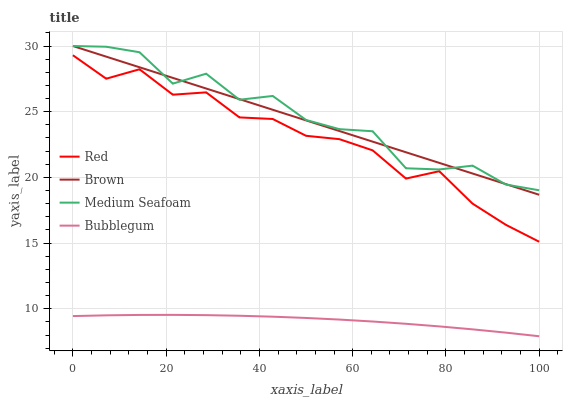Does Bubblegum have the minimum area under the curve?
Answer yes or no. Yes. Does Medium Seafoam have the maximum area under the curve?
Answer yes or no. Yes. Does Medium Seafoam have the minimum area under the curve?
Answer yes or no. No. Does Bubblegum have the maximum area under the curve?
Answer yes or no. No. Is Brown the smoothest?
Answer yes or no. Yes. Is Medium Seafoam the roughest?
Answer yes or no. Yes. Is Bubblegum the smoothest?
Answer yes or no. No. Is Bubblegum the roughest?
Answer yes or no. No. Does Bubblegum have the lowest value?
Answer yes or no. Yes. Does Medium Seafoam have the lowest value?
Answer yes or no. No. Does Medium Seafoam have the highest value?
Answer yes or no. Yes. Does Bubblegum have the highest value?
Answer yes or no. No. Is Bubblegum less than Medium Seafoam?
Answer yes or no. Yes. Is Medium Seafoam greater than Red?
Answer yes or no. Yes. Does Brown intersect Medium Seafoam?
Answer yes or no. Yes. Is Brown less than Medium Seafoam?
Answer yes or no. No. Is Brown greater than Medium Seafoam?
Answer yes or no. No. Does Bubblegum intersect Medium Seafoam?
Answer yes or no. No. 